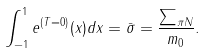<formula> <loc_0><loc_0><loc_500><loc_500>\int _ { - 1 } ^ { 1 } e ^ { ( T = 0 ) } ( x ) d x = \bar { \sigma } = \frac { \sum _ { \pi N } } { m _ { 0 } } .</formula> 